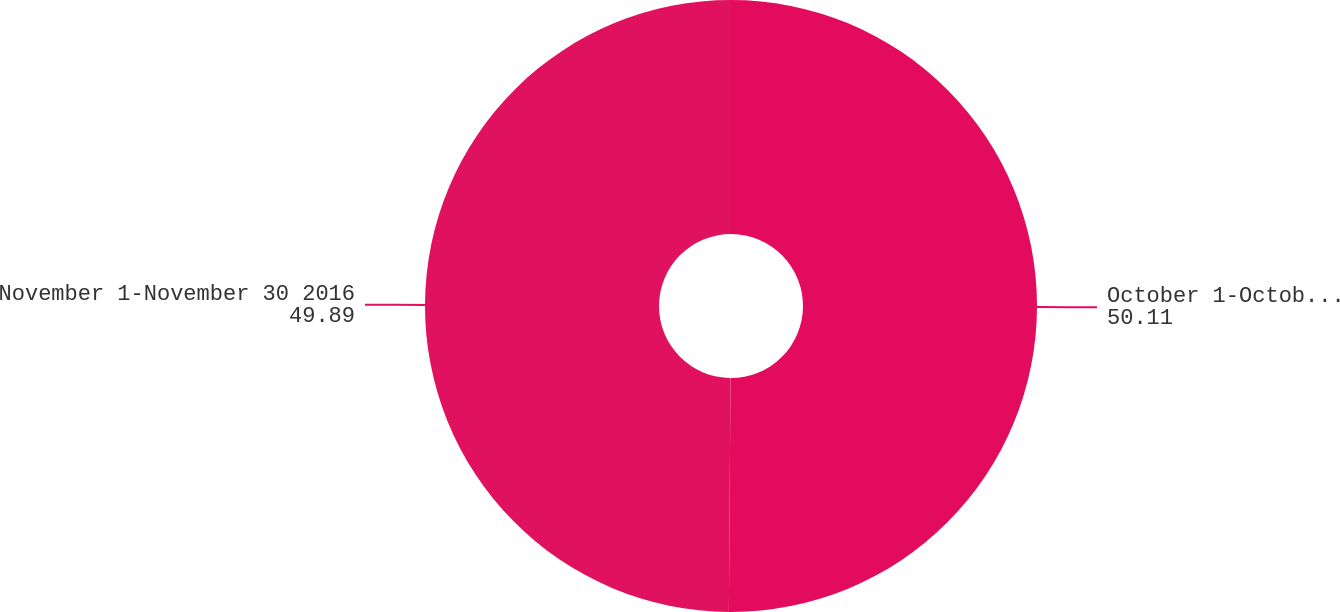Convert chart. <chart><loc_0><loc_0><loc_500><loc_500><pie_chart><fcel>October 1-October 31 2016<fcel>November 1-November 30 2016<nl><fcel>50.11%<fcel>49.89%<nl></chart> 